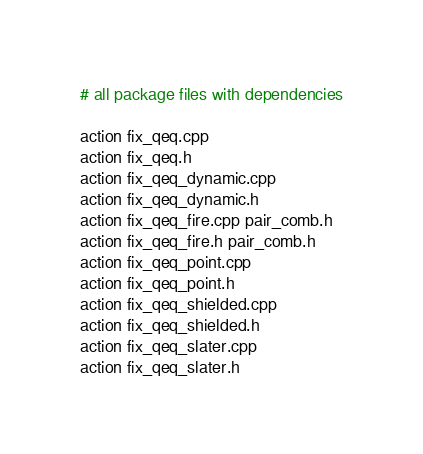Convert code to text. <code><loc_0><loc_0><loc_500><loc_500><_Bash_>
# all package files with dependencies

action fix_qeq.cpp
action fix_qeq.h
action fix_qeq_dynamic.cpp
action fix_qeq_dynamic.h
action fix_qeq_fire.cpp pair_comb.h
action fix_qeq_fire.h pair_comb.h
action fix_qeq_point.cpp
action fix_qeq_point.h
action fix_qeq_shielded.cpp
action fix_qeq_shielded.h
action fix_qeq_slater.cpp
action fix_qeq_slater.h
</code> 